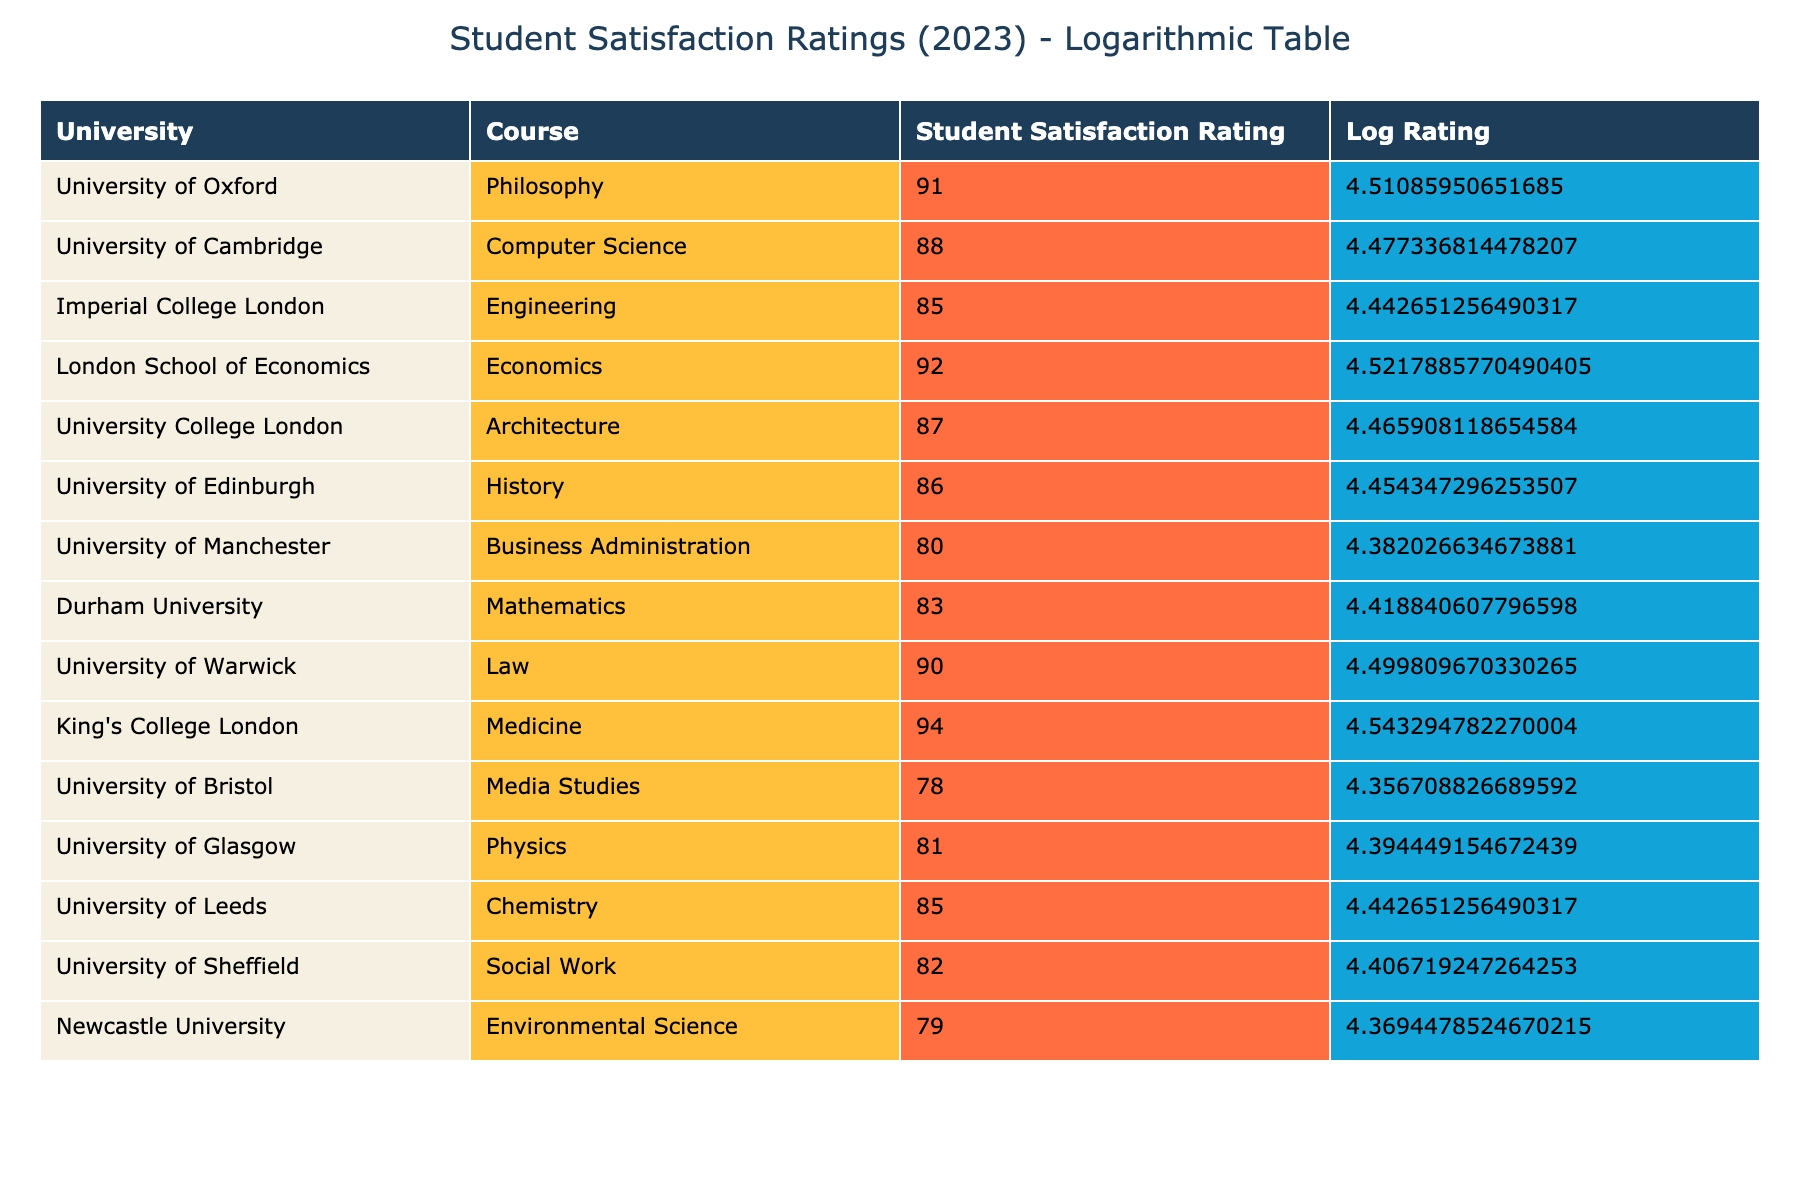What is the highest student satisfaction rating? The table shows the student satisfaction ratings for various courses at UK universities. Looking through the ratings, King's College London has the highest rating of 94.
Answer: 94 What is the average student satisfaction rating across all courses listed? To find the average, I will sum all the ratings: (91 + 88 + 85 + 92 + 87 + 86 + 80 + 83 + 90 + 94 + 78 + 81 + 85 + 82 + 79) = 1,325. Then, divide by the number of universities (15): 1,325 / 15 = 88.33, rounding gives an average of approximately 88.
Answer: 88.33 Is the student satisfaction rating for Economics higher than that for Philosophy? The table shows that Economics, offered by London School of Economics, has a satisfaction rating of 92, while Philosophy at University of Oxford has a rating of 91. Since 92 is greater than 91, the satisfaction is higher for Economics.
Answer: Yes How many courses have a satisfaction rating above 85? I will check each course's rating: Philosophy (91), Computer Science (88), Economics (92), Architecture (87), History (86), Law (90), and Medicine (94) all have ratings above 85. Counting these, there are 7 courses above 85.
Answer: 7 Which university has the lowest student satisfaction rating and what is that rating? By examining the ratings, the lowest satisfaction rating is 78, which corresponds to Media Studies at University of Bristol. Thus, this university has the lowest rating.
Answer: University of Bristol, 78 